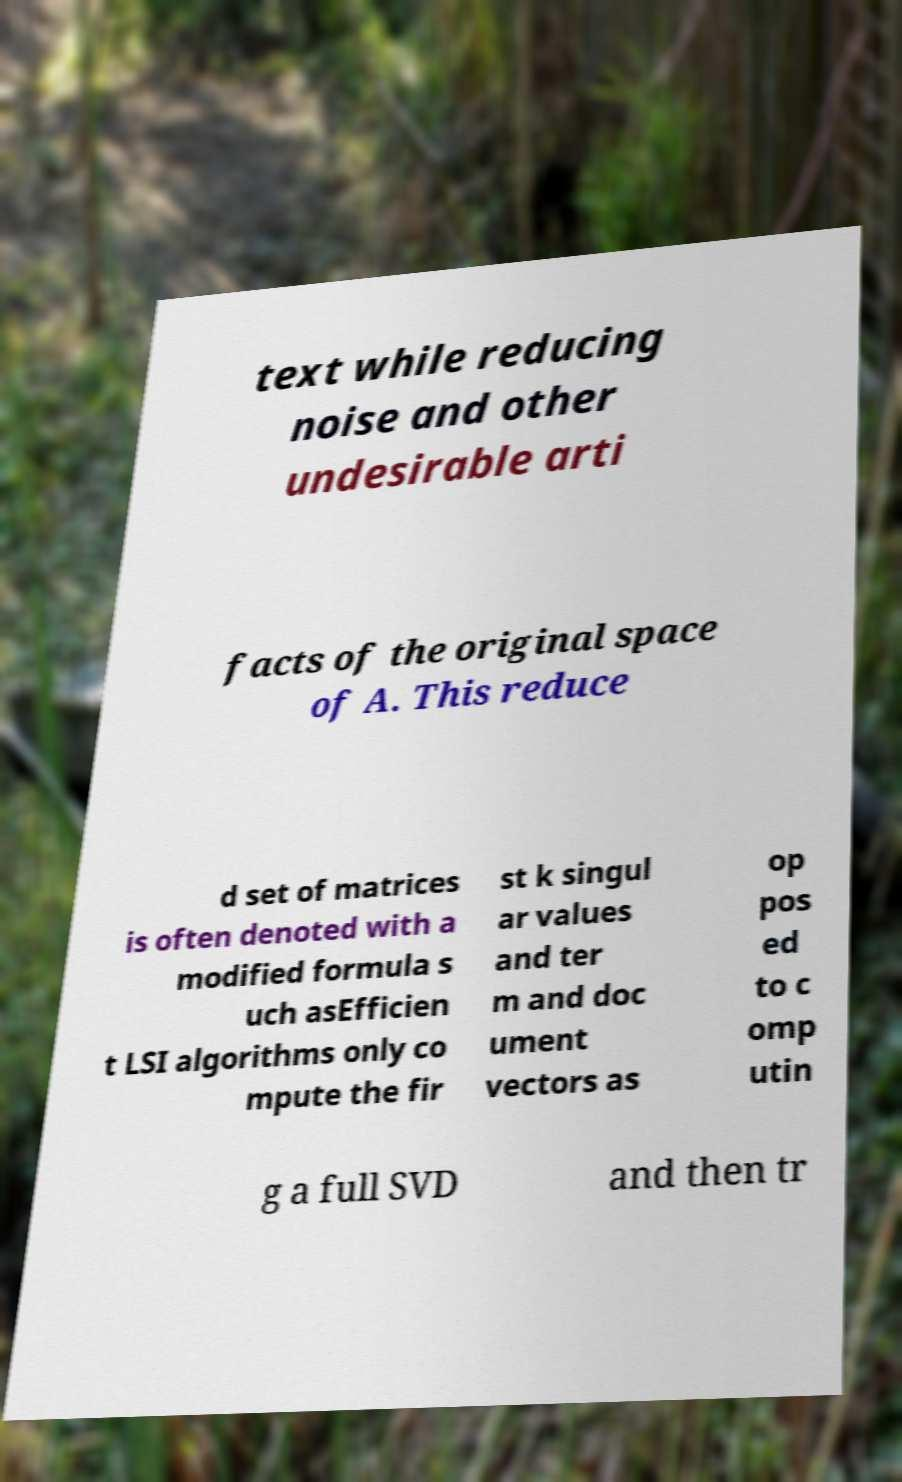There's text embedded in this image that I need extracted. Can you transcribe it verbatim? text while reducing noise and other undesirable arti facts of the original space of A. This reduce d set of matrices is often denoted with a modified formula s uch asEfficien t LSI algorithms only co mpute the fir st k singul ar values and ter m and doc ument vectors as op pos ed to c omp utin g a full SVD and then tr 